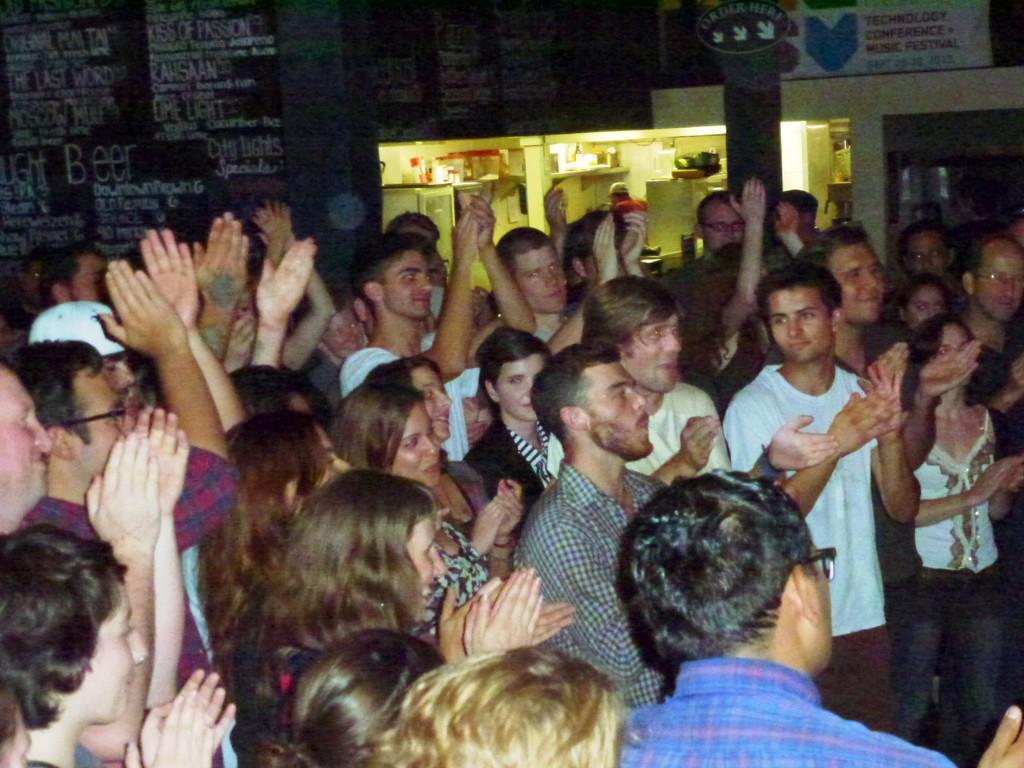What are the people in the image doing? The people in the image are standing at the bottom and clapping. What can be seen in the background of the image? In the background, there are boards, poles, lights, and other unspecified objects. Can you describe the objects in the background in more detail? The background features boards, poles, and lights, but the other unspecified objects cannot be described further without additional information. What type of vase is placed on the nose of the person in the image? There is no vase or person with a nose present in the image. How is the wrench being used by the people in the image? There is no wrench present in the image; the people are clapping. 